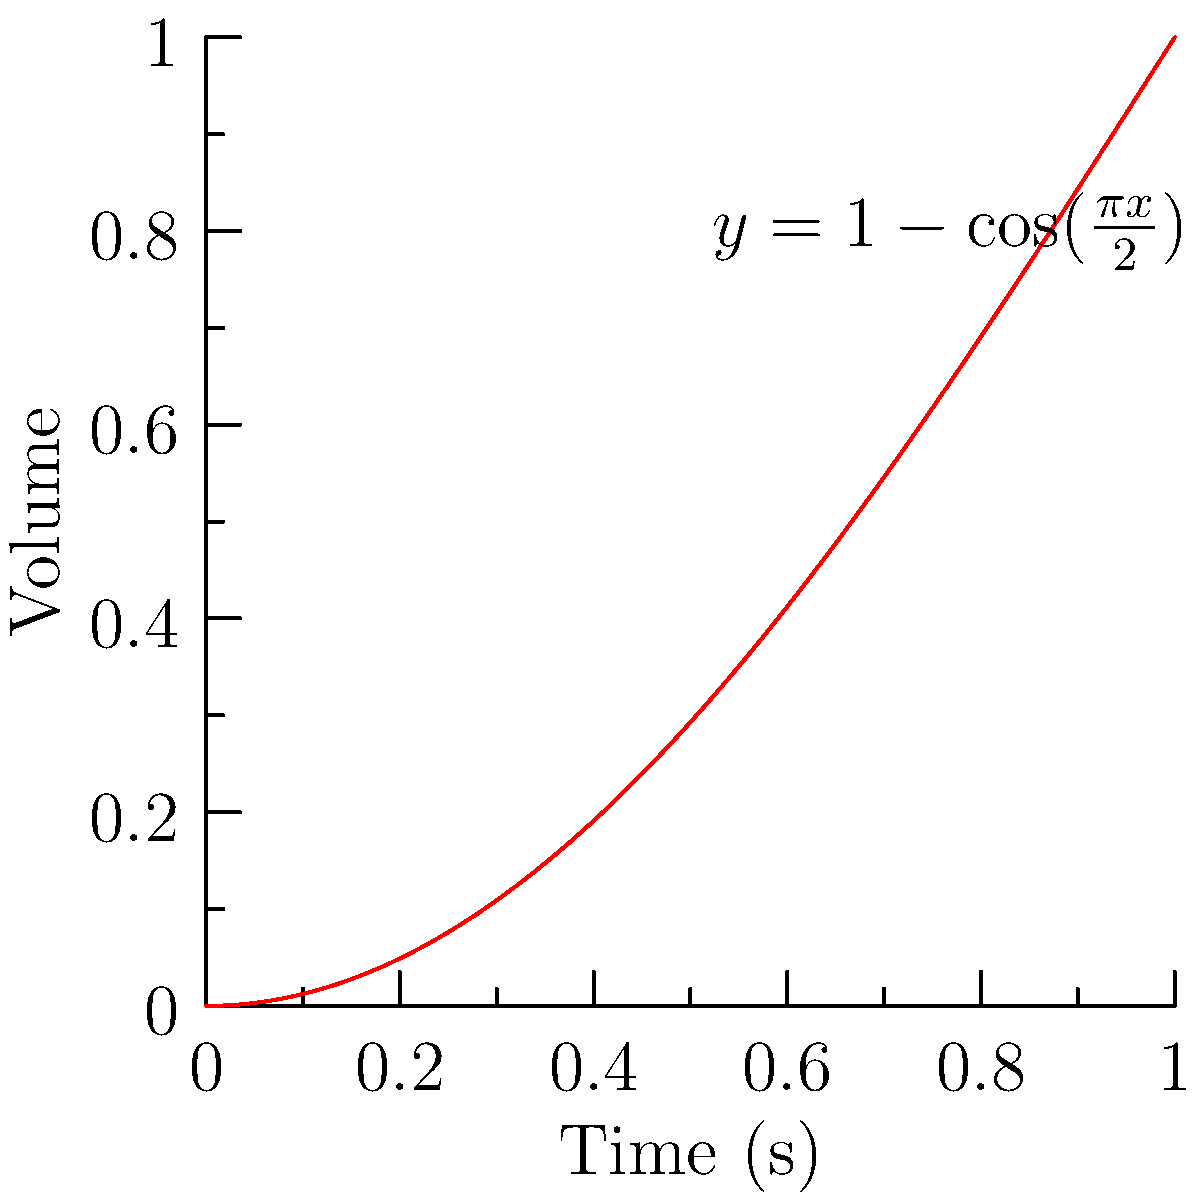As a music producer for indie games, you want to implement a smooth volume fade-in curve for transitioning between game scenes. You decide to use the function $f(x)=1-\cos(\frac{\pi x}{2})$ for $x \in [0,1]$, where $x$ represents time in seconds and $f(x)$ represents the volume level. At what time $t$ does the volume reach half of its maximum level, and what is the rate of volume change at this point? 1) First, we need to find when the volume is at half its maximum level. The maximum volume is 1, so we're looking for $f(t) = 0.5$.

2) Set up the equation:
   $0.5 = 1 - \cos(\frac{\pi t}{2})$

3) Solve for $t$:
   $\cos(\frac{\pi t}{2}) = 0.5$
   $\frac{\pi t}{2} = \arccos(0.5) = \frac{\pi}{3}$
   $t = \frac{2}{3}$ seconds

4) To find the rate of volume change at this point, we need to calculate the derivative of $f(x)$ and evaluate it at $t = \frac{2}{3}$.

5) The derivative of $f(x)$ is:
   $f'(x) = \frac{\pi}{2} \sin(\frac{\pi x}{2})$

6) Evaluate $f'(\frac{2}{3})$:
   $f'(\frac{2}{3}) = \frac{\pi}{2} \sin(\frac{\pi}{3}) = \frac{\pi}{2} \cdot \frac{\sqrt{3}}{2} = \frac{\pi\sqrt{3}}{4}$

Therefore, the volume reaches half of its maximum level at $t = \frac{2}{3}$ seconds, and the rate of volume change at this point is $\frac{\pi\sqrt{3}}{4}$ units per second.
Answer: $t = \frac{2}{3}$ s, rate = $\frac{\pi\sqrt{3}}{4}$ units/s 